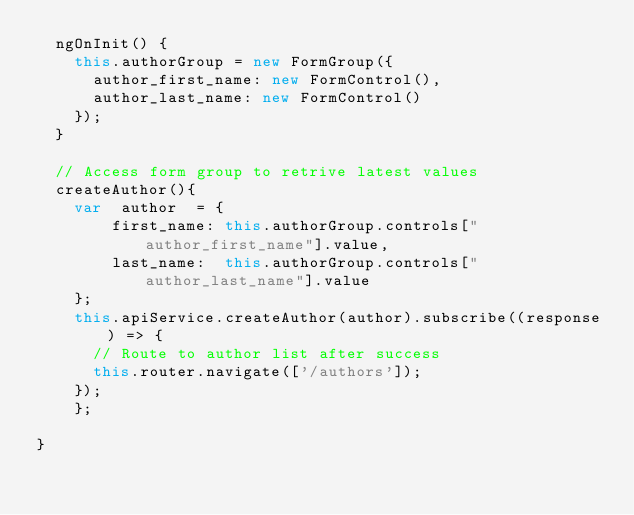<code> <loc_0><loc_0><loc_500><loc_500><_TypeScript_>  ngOnInit() {
    this.authorGroup = new FormGroup({
      author_first_name: new FormControl(),
      author_last_name: new FormControl()
    });
  }

  // Access form group to retrive latest values
  createAuthor(){
    var  author  = {
        first_name: this.authorGroup.controls["author_first_name"].value,
        last_name:  this.authorGroup.controls["author_last_name"].value
    };
    this.apiService.createAuthor(author).subscribe((response) => {
      // Route to author list after success
      this.router.navigate(['/authors']);
    });
    };

}
</code> 